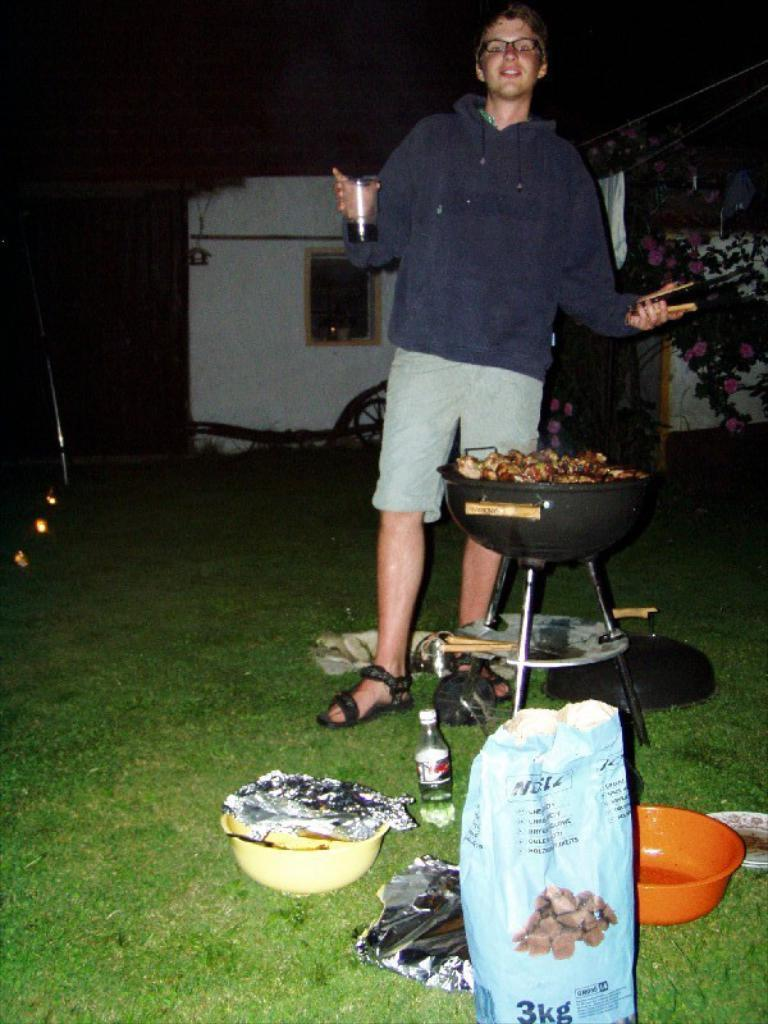<image>
Provide a brief description of the given image. A man is cooking something outside in front of a 3 kilogram bag of dog food. 